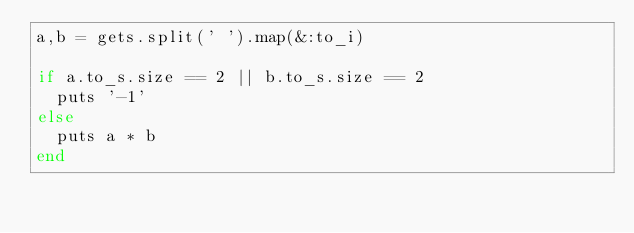<code> <loc_0><loc_0><loc_500><loc_500><_Ruby_>a,b = gets.split(' ').map(&:to_i)

if a.to_s.size == 2 || b.to_s.size == 2
  puts '-1'
else
  puts a * b
end</code> 